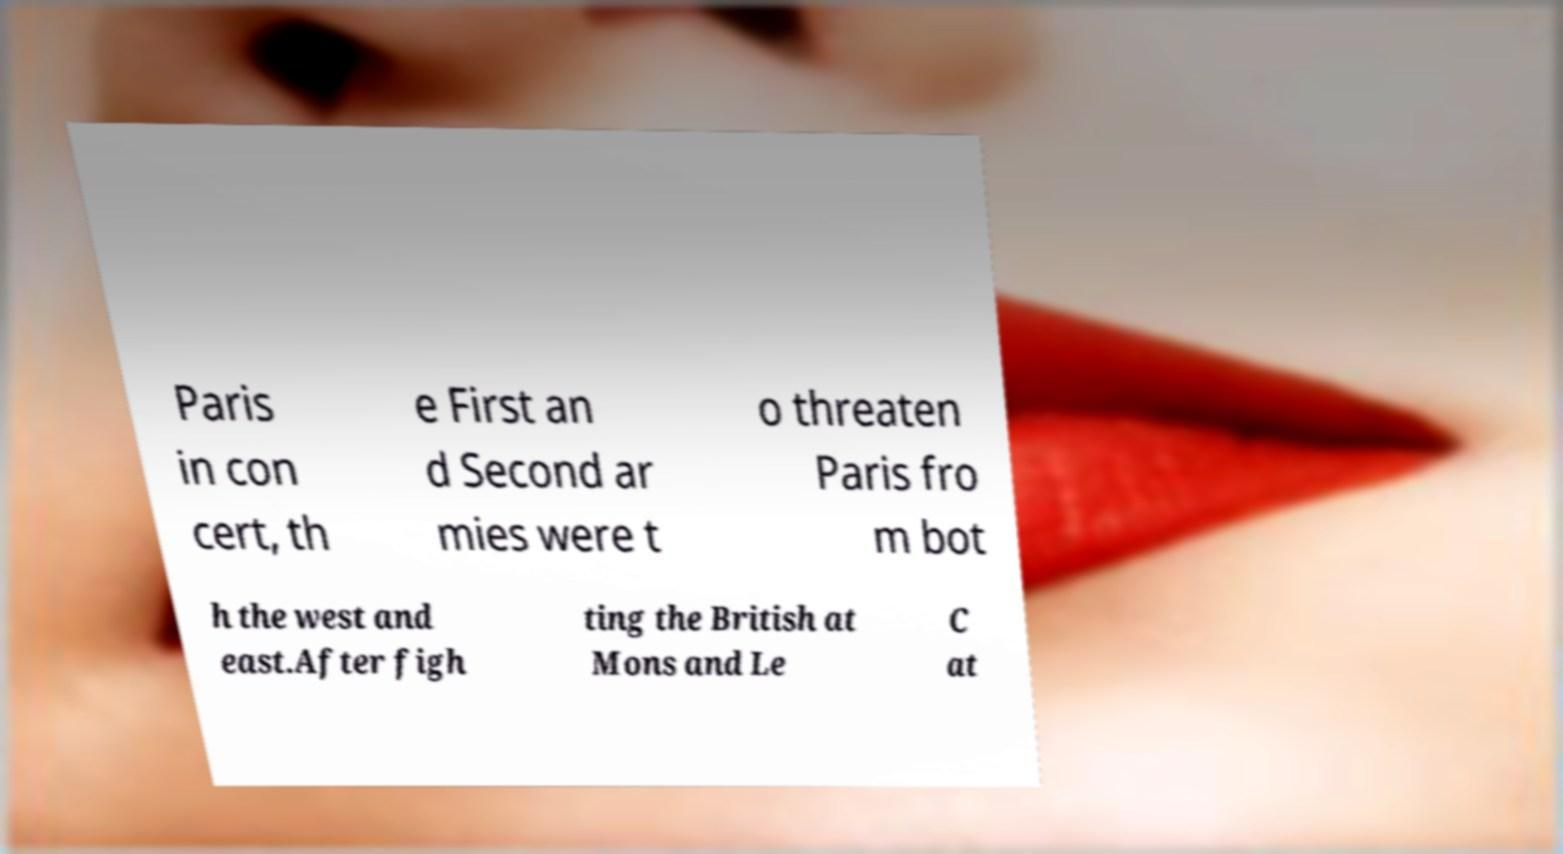What messages or text are displayed in this image? I need them in a readable, typed format. Paris in con cert, th e First an d Second ar mies were t o threaten Paris fro m bot h the west and east.After figh ting the British at Mons and Le C at 